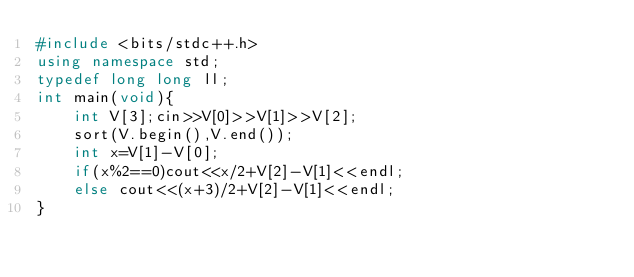Convert code to text. <code><loc_0><loc_0><loc_500><loc_500><_C++_>#include <bits/stdc++.h>
using namespace std;
typedef long long ll;
int main(void){
    int V[3];cin>>V[0]>>V[1]>>V[2];
    sort(V.begin(),V.end());
    int x=V[1]-V[0];
    if(x%2==0)cout<<x/2+V[2]-V[1]<<endl;
    else cout<<(x+3)/2+V[2]-V[1]<<endl;
}
</code> 